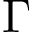<formula> <loc_0><loc_0><loc_500><loc_500>\Gamma</formula> 